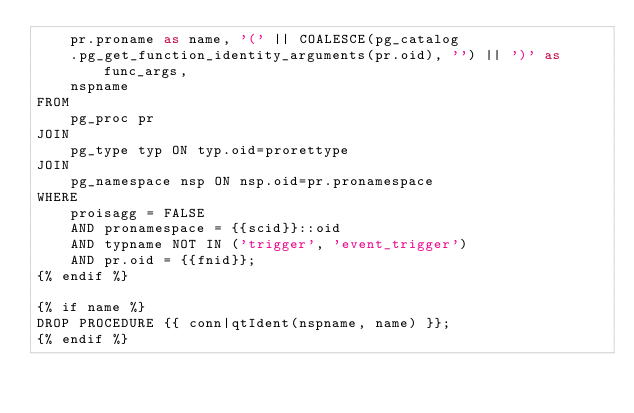Convert code to text. <code><loc_0><loc_0><loc_500><loc_500><_SQL_>    pr.proname as name, '(' || COALESCE(pg_catalog
    .pg_get_function_identity_arguments(pr.oid), '') || ')' as func_args,
    nspname
FROM
    pg_proc pr
JOIN
    pg_type typ ON typ.oid=prorettype
JOIN
    pg_namespace nsp ON nsp.oid=pr.pronamespace
WHERE
    proisagg = FALSE
    AND pronamespace = {{scid}}::oid
    AND typname NOT IN ('trigger', 'event_trigger')
    AND pr.oid = {{fnid}};
{% endif %}

{% if name %}
DROP PROCEDURE {{ conn|qtIdent(nspname, name) }};
{% endif %}
</code> 